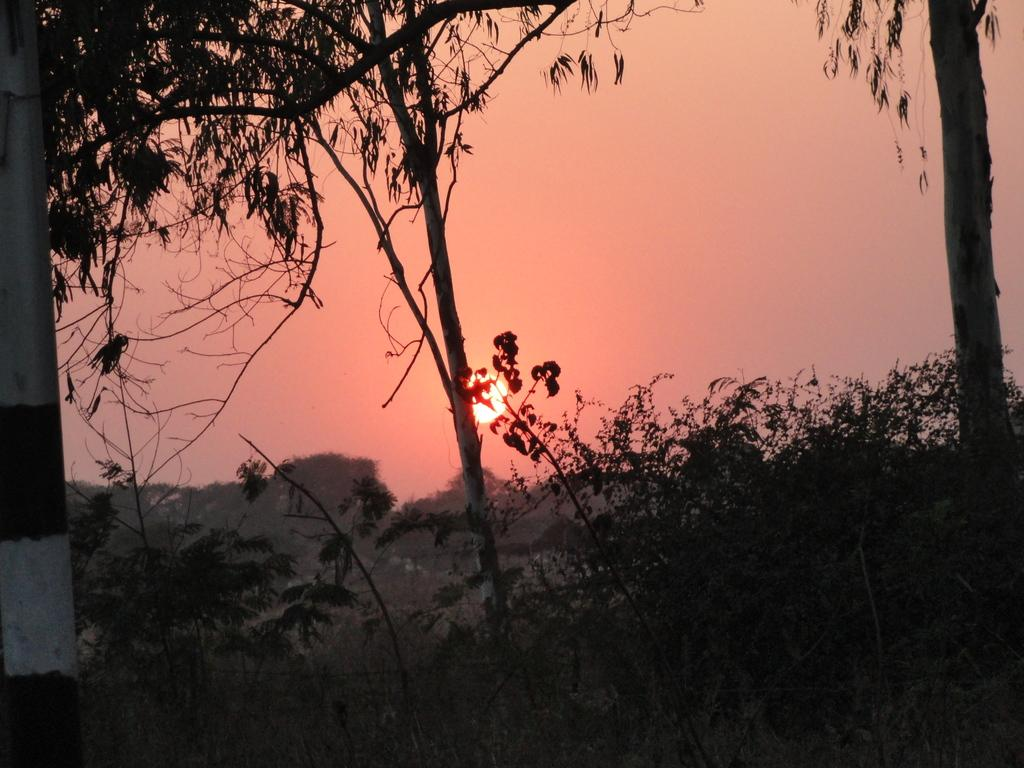What is the main object in the image? There is a pole in the image. What can be seen behind the pole? There are plants and trees behind the pole. What is the condition of the sky in the image? The sun is visible in the sky in the image. What type of love letters can be seen in the mailbox in the image? There is no mailbox present in the image, so it is not possible to determine if there are any love letters. 